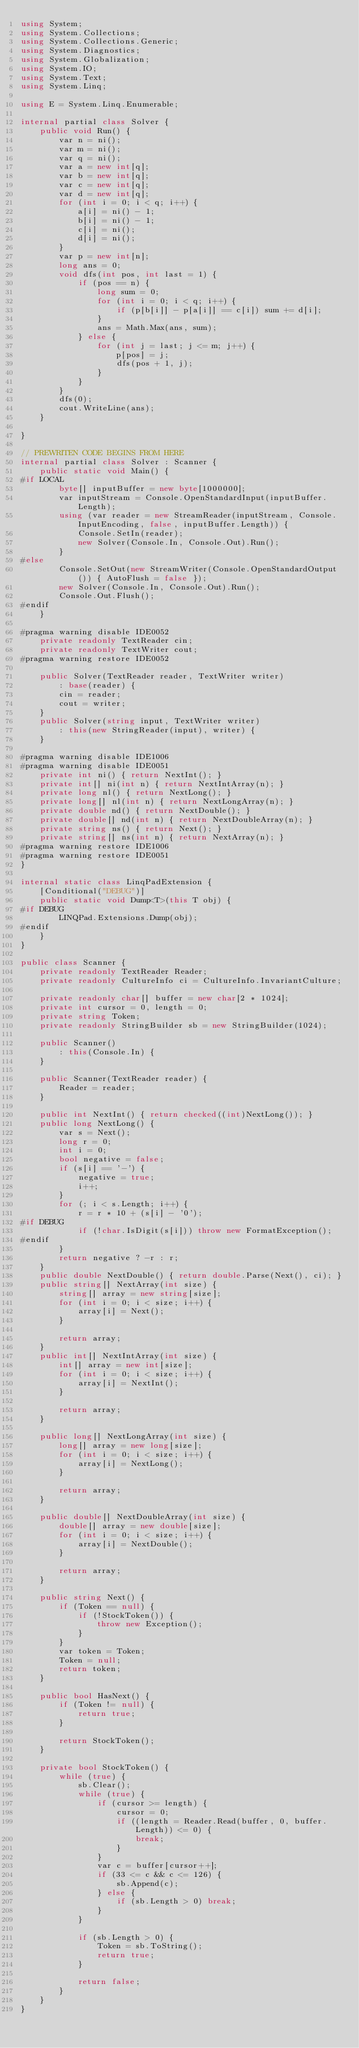Convert code to text. <code><loc_0><loc_0><loc_500><loc_500><_C#_>using System;
using System.Collections;
using System.Collections.Generic;
using System.Diagnostics;
using System.Globalization;
using System.IO;
using System.Text;
using System.Linq;

using E = System.Linq.Enumerable;

internal partial class Solver {
    public void Run() {
        var n = ni();
        var m = ni();
        var q = ni();
        var a = new int[q];
        var b = new int[q];
        var c = new int[q];
        var d = new int[q];
        for (int i = 0; i < q; i++) {
            a[i] = ni() - 1;
            b[i] = ni() - 1;
            c[i] = ni();
            d[i] = ni();
        }
        var p = new int[n];
        long ans = 0;
        void dfs(int pos, int last = 1) {
            if (pos == n) {
                long sum = 0;
                for (int i = 0; i < q; i++) {
                    if (p[b[i]] - p[a[i]] == c[i]) sum += d[i];
                }
                ans = Math.Max(ans, sum);
            } else {
                for (int j = last; j <= m; j++) {
                    p[pos] = j;
                    dfs(pos + 1, j);
                }
            }
        }
        dfs(0);
        cout.WriteLine(ans);
    }

}

// PREWRITEN CODE BEGINS FROM HERE
internal partial class Solver : Scanner {
    public static void Main() {
#if LOCAL
        byte[] inputBuffer = new byte[1000000];
        var inputStream = Console.OpenStandardInput(inputBuffer.Length);
        using (var reader = new StreamReader(inputStream, Console.InputEncoding, false, inputBuffer.Length)) {
            Console.SetIn(reader);
            new Solver(Console.In, Console.Out).Run();
        }
#else
        Console.SetOut(new StreamWriter(Console.OpenStandardOutput()) { AutoFlush = false });
        new Solver(Console.In, Console.Out).Run();
        Console.Out.Flush();
#endif
    }

#pragma warning disable IDE0052
    private readonly TextReader cin;
    private readonly TextWriter cout;
#pragma warning restore IDE0052

    public Solver(TextReader reader, TextWriter writer)
        : base(reader) {
        cin = reader;
        cout = writer;
    }
    public Solver(string input, TextWriter writer)
        : this(new StringReader(input), writer) {
    }

#pragma warning disable IDE1006
#pragma warning disable IDE0051
    private int ni() { return NextInt(); }
    private int[] ni(int n) { return NextIntArray(n); }
    private long nl() { return NextLong(); }
    private long[] nl(int n) { return NextLongArray(n); }
    private double nd() { return NextDouble(); }
    private double[] nd(int n) { return NextDoubleArray(n); }
    private string ns() { return Next(); }
    private string[] ns(int n) { return NextArray(n); }
#pragma warning restore IDE1006
#pragma warning restore IDE0051
}

internal static class LinqPadExtension {
    [Conditional("DEBUG")]
    public static void Dump<T>(this T obj) {
#if DEBUG
        LINQPad.Extensions.Dump(obj);
#endif
    }
}

public class Scanner {
    private readonly TextReader Reader;
    private readonly CultureInfo ci = CultureInfo.InvariantCulture;

    private readonly char[] buffer = new char[2 * 1024];
    private int cursor = 0, length = 0;
    private string Token;
    private readonly StringBuilder sb = new StringBuilder(1024);

    public Scanner()
        : this(Console.In) {
    }

    public Scanner(TextReader reader) {
        Reader = reader;
    }

    public int NextInt() { return checked((int)NextLong()); }
    public long NextLong() {
        var s = Next();
        long r = 0;
        int i = 0;
        bool negative = false;
        if (s[i] == '-') {
            negative = true;
            i++;
        }
        for (; i < s.Length; i++) {
            r = r * 10 + (s[i] - '0');
#if DEBUG
            if (!char.IsDigit(s[i])) throw new FormatException();
#endif
        }
        return negative ? -r : r;
    }
    public double NextDouble() { return double.Parse(Next(), ci); }
    public string[] NextArray(int size) {
        string[] array = new string[size];
        for (int i = 0; i < size; i++) {
            array[i] = Next();
        }

        return array;
    }
    public int[] NextIntArray(int size) {
        int[] array = new int[size];
        for (int i = 0; i < size; i++) {
            array[i] = NextInt();
        }

        return array;
    }

    public long[] NextLongArray(int size) {
        long[] array = new long[size];
        for (int i = 0; i < size; i++) {
            array[i] = NextLong();
        }

        return array;
    }

    public double[] NextDoubleArray(int size) {
        double[] array = new double[size];
        for (int i = 0; i < size; i++) {
            array[i] = NextDouble();
        }

        return array;
    }

    public string Next() {
        if (Token == null) {
            if (!StockToken()) {
                throw new Exception();
            }
        }
        var token = Token;
        Token = null;
        return token;
    }

    public bool HasNext() {
        if (Token != null) {
            return true;
        }

        return StockToken();
    }

    private bool StockToken() {
        while (true) {
            sb.Clear();
            while (true) {
                if (cursor >= length) {
                    cursor = 0;
                    if ((length = Reader.Read(buffer, 0, buffer.Length)) <= 0) {
                        break;
                    }
                }
                var c = buffer[cursor++];
                if (33 <= c && c <= 126) {
                    sb.Append(c);
                } else {
                    if (sb.Length > 0) break;
                }
            }

            if (sb.Length > 0) {
                Token = sb.ToString();
                return true;
            }

            return false;
        }
    }
}</code> 